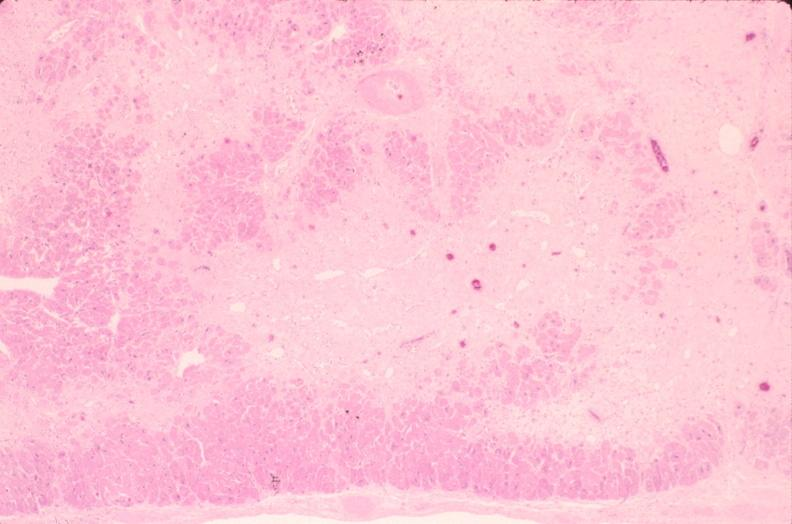does this image show heart, fibrosis, chronic ischemic heart disease?
Answer the question using a single word or phrase. Yes 